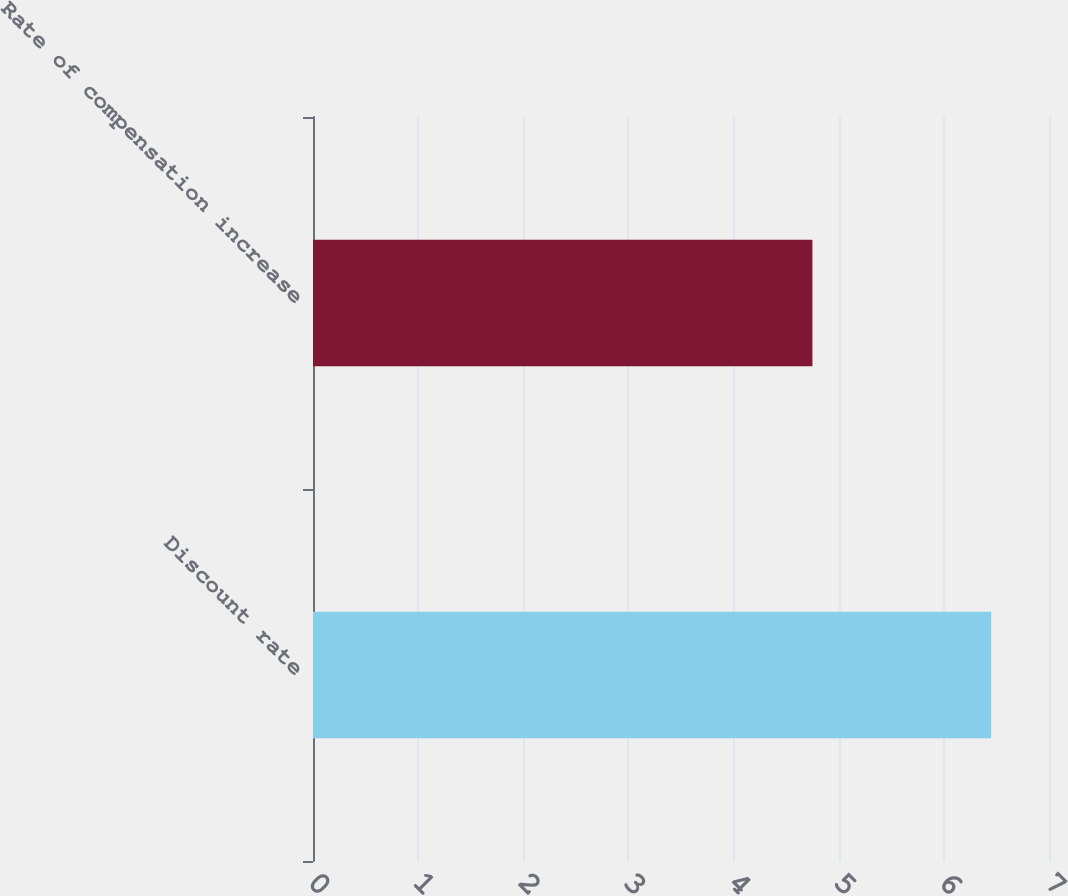<chart> <loc_0><loc_0><loc_500><loc_500><bar_chart><fcel>Discount rate<fcel>Rate of compensation increase<nl><fcel>6.45<fcel>4.75<nl></chart> 